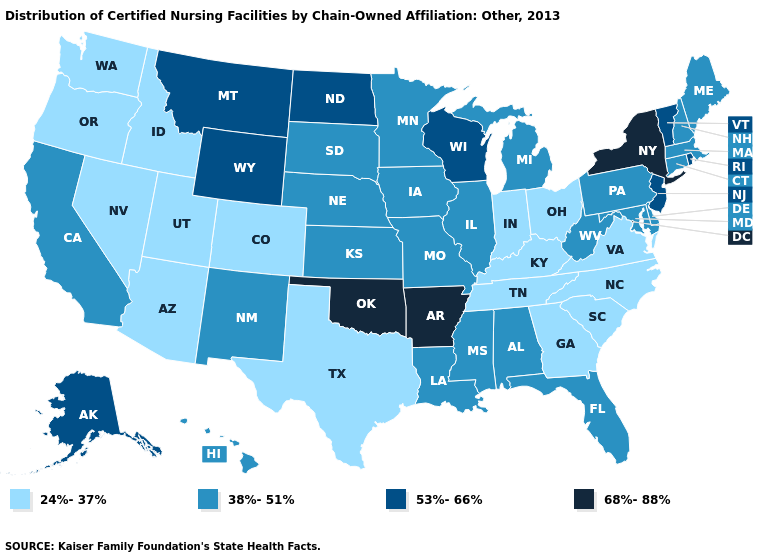Does Oregon have the lowest value in the West?
Concise answer only. Yes. Does Kentucky have a lower value than Louisiana?
Answer briefly. Yes. What is the lowest value in the MidWest?
Be succinct. 24%-37%. What is the highest value in states that border Florida?
Quick response, please. 38%-51%. What is the value of Texas?
Be succinct. 24%-37%. Does the map have missing data?
Write a very short answer. No. What is the value of Texas?
Concise answer only. 24%-37%. What is the highest value in the USA?
Concise answer only. 68%-88%. What is the lowest value in the MidWest?
Concise answer only. 24%-37%. What is the value of Illinois?
Be succinct. 38%-51%. What is the highest value in states that border New Hampshire?
Be succinct. 53%-66%. What is the value of New Mexico?
Concise answer only. 38%-51%. Does Connecticut have the lowest value in the USA?
Keep it brief. No. 